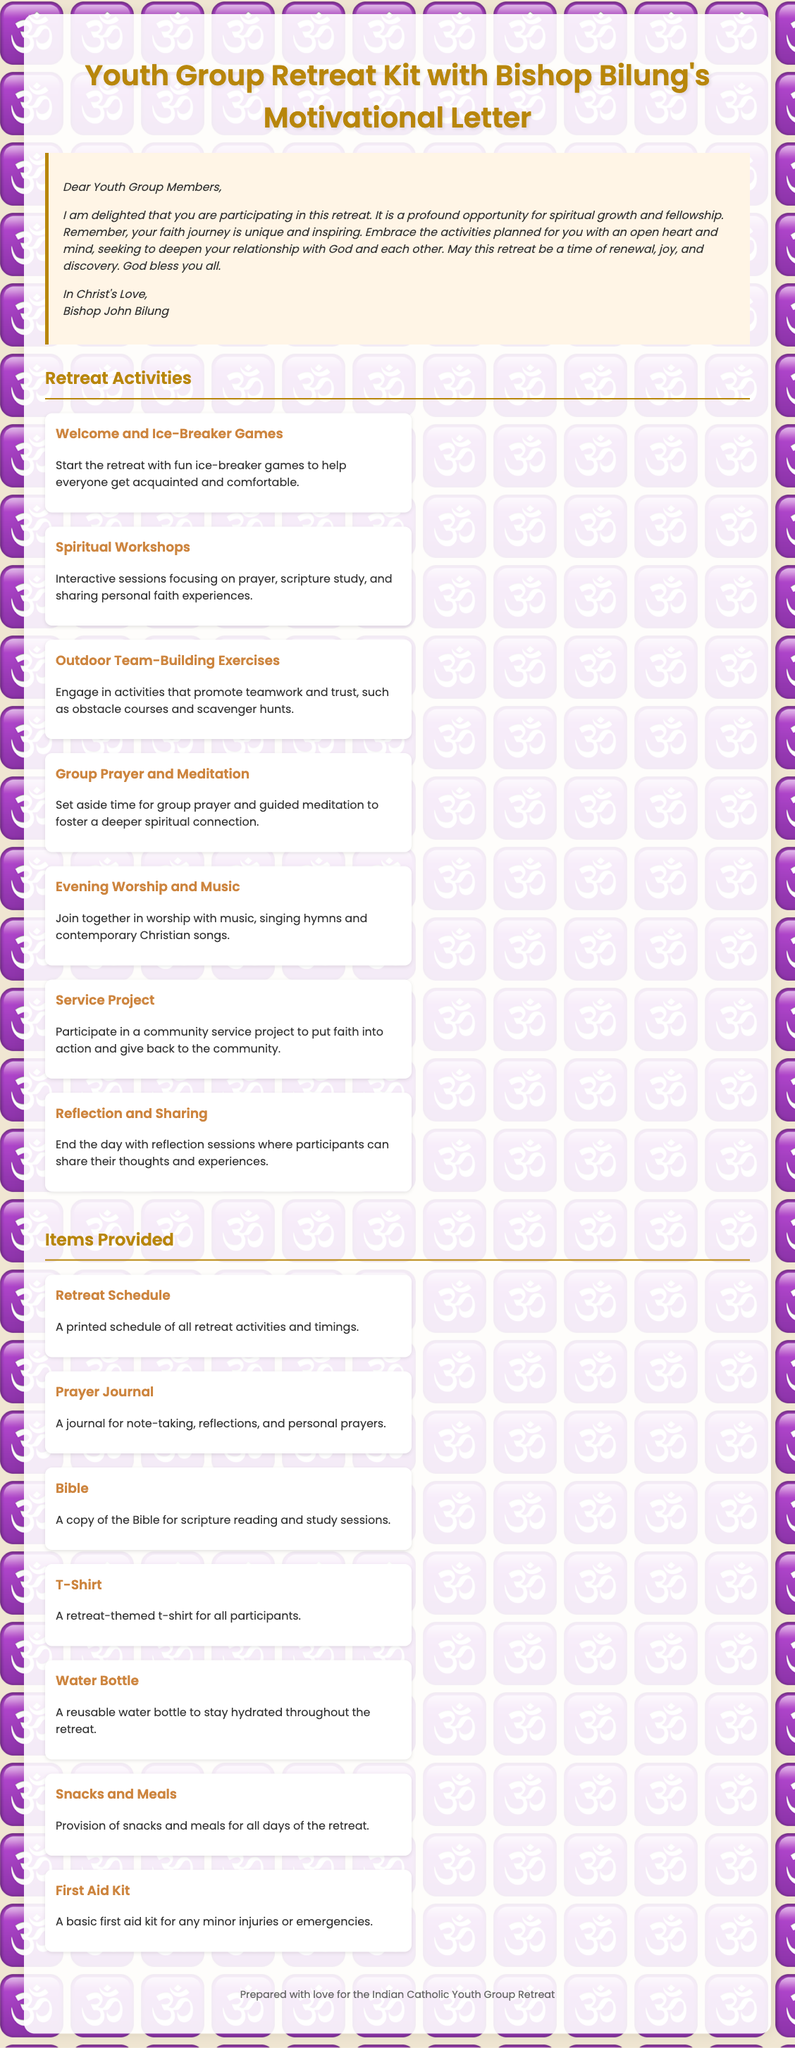What is the title of the document? The title is prominently displayed at the top of the document and provides a clear overview of the kit's purpose.
Answer: Youth Group Retreat Kit with Bishop Bilung's Motivational Letter Who wrote the motivational letter? The motivational letter is signed at the end, indicating the author of the letter.
Answer: Bishop John Bilung How many retreat activities are listed? Counting the retreat activities enumerated in the document leads to the total number present.
Answer: Seven What is one of the provided items for the retreat? The items provided section lists several items available for participants.
Answer: Bible What is the main theme of the retreat according to Bishop Bilung? The letter emphasizes the significance of the faith journey, which gives insight into the overall retreat theme.
Answer: Spiritual growth Which activity involves teamwork? The activities section categorizes different activities, including those focused on teamwork.
Answer: Outdoor Team-Building Exercises What type of journal is provided? The items provided include a specific type of journal that serves a particular purpose during the retreat.
Answer: Prayer Journal What is mentioned as a necessity for staying hydrated? The items section explicitly mentions a specific item aimed at helping participants stay hydrated during the activities.
Answer: Water Bottle 